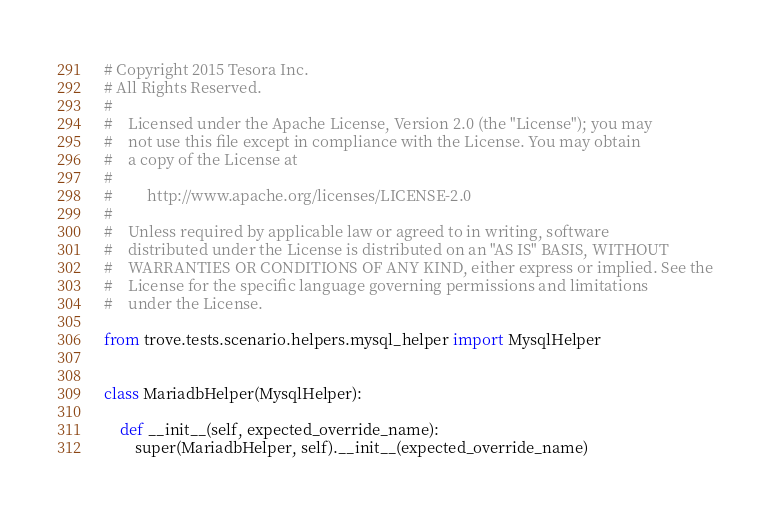Convert code to text. <code><loc_0><loc_0><loc_500><loc_500><_Python_># Copyright 2015 Tesora Inc.
# All Rights Reserved.
#
#    Licensed under the Apache License, Version 2.0 (the "License"); you may
#    not use this file except in compliance with the License. You may obtain
#    a copy of the License at
#
#         http://www.apache.org/licenses/LICENSE-2.0
#
#    Unless required by applicable law or agreed to in writing, software
#    distributed under the License is distributed on an "AS IS" BASIS, WITHOUT
#    WARRANTIES OR CONDITIONS OF ANY KIND, either express or implied. See the
#    License for the specific language governing permissions and limitations
#    under the License.

from trove.tests.scenario.helpers.mysql_helper import MysqlHelper


class MariadbHelper(MysqlHelper):

    def __init__(self, expected_override_name):
        super(MariadbHelper, self).__init__(expected_override_name)
</code> 